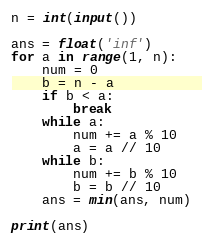Convert code to text. <code><loc_0><loc_0><loc_500><loc_500><_Python_>n = int(input())

ans = float('inf')
for a in range(1, n):
    num = 0
    b = n - a
    if b < a:
        break
    while a:
        num += a % 10
        a = a // 10
    while b:
        num += b % 10
        b = b // 10
    ans = min(ans, num)

print(ans)


</code> 